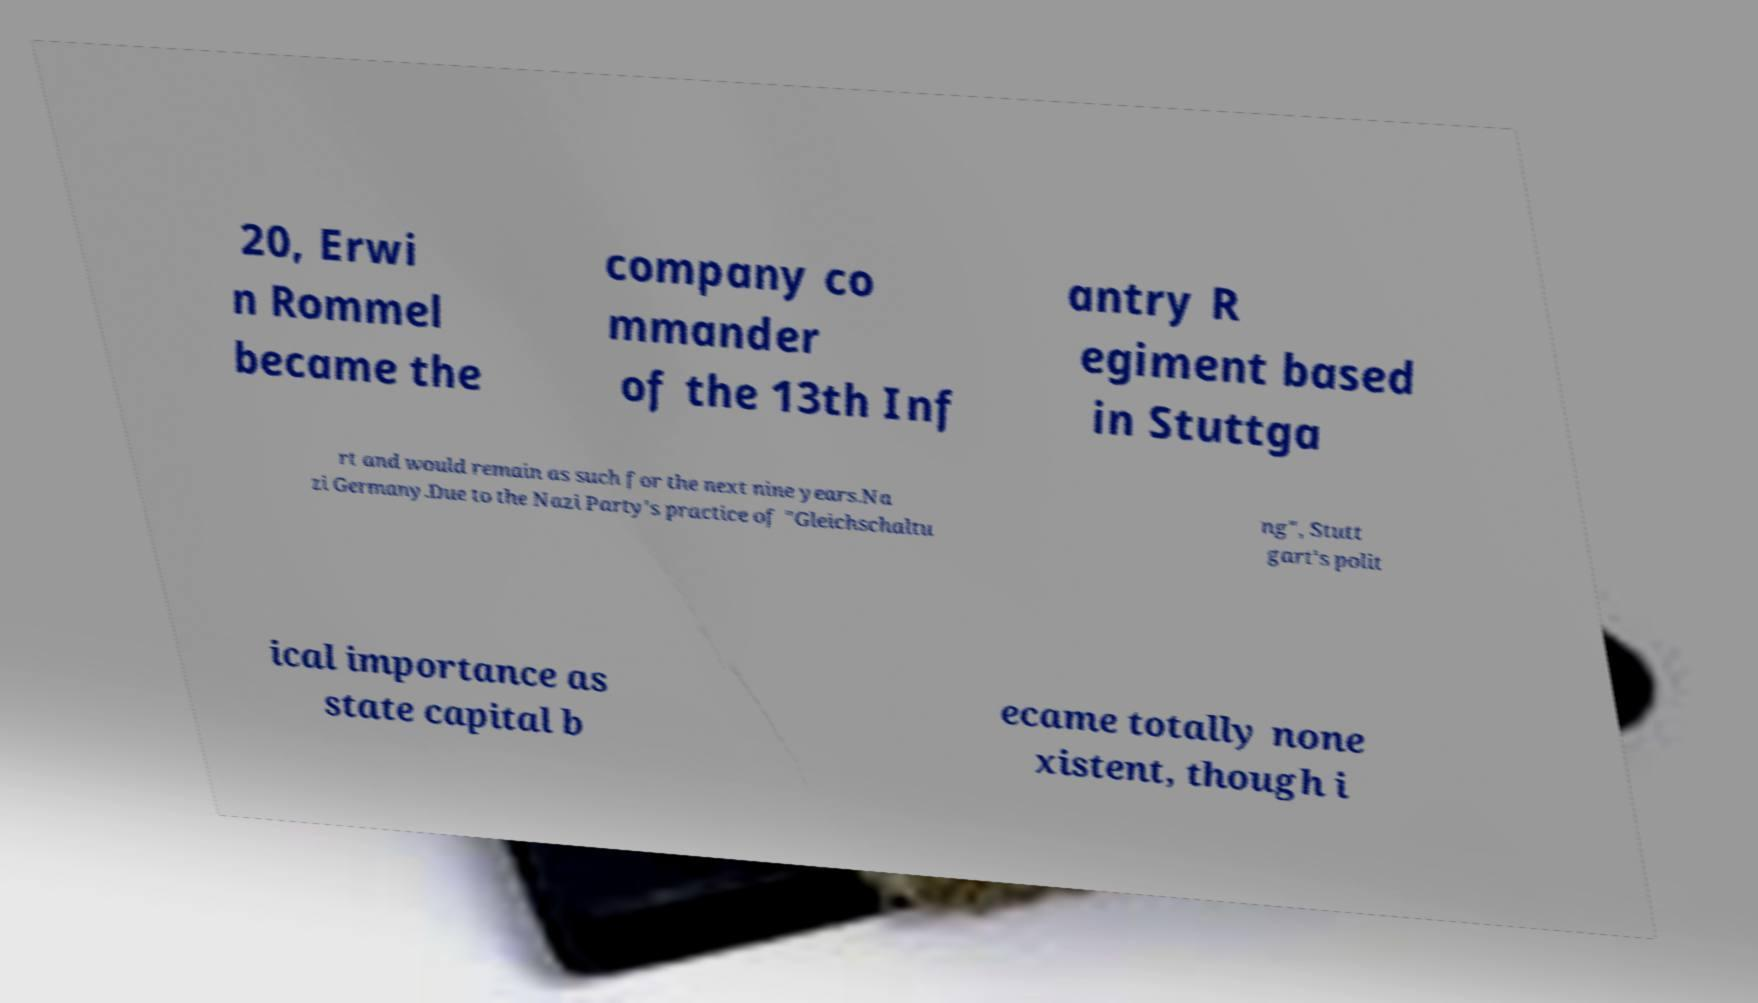Can you read and provide the text displayed in the image?This photo seems to have some interesting text. Can you extract and type it out for me? 20, Erwi n Rommel became the company co mmander of the 13th Inf antry R egiment based in Stuttga rt and would remain as such for the next nine years.Na zi Germany.Due to the Nazi Party's practice of "Gleichschaltu ng", Stutt gart's polit ical importance as state capital b ecame totally none xistent, though i 